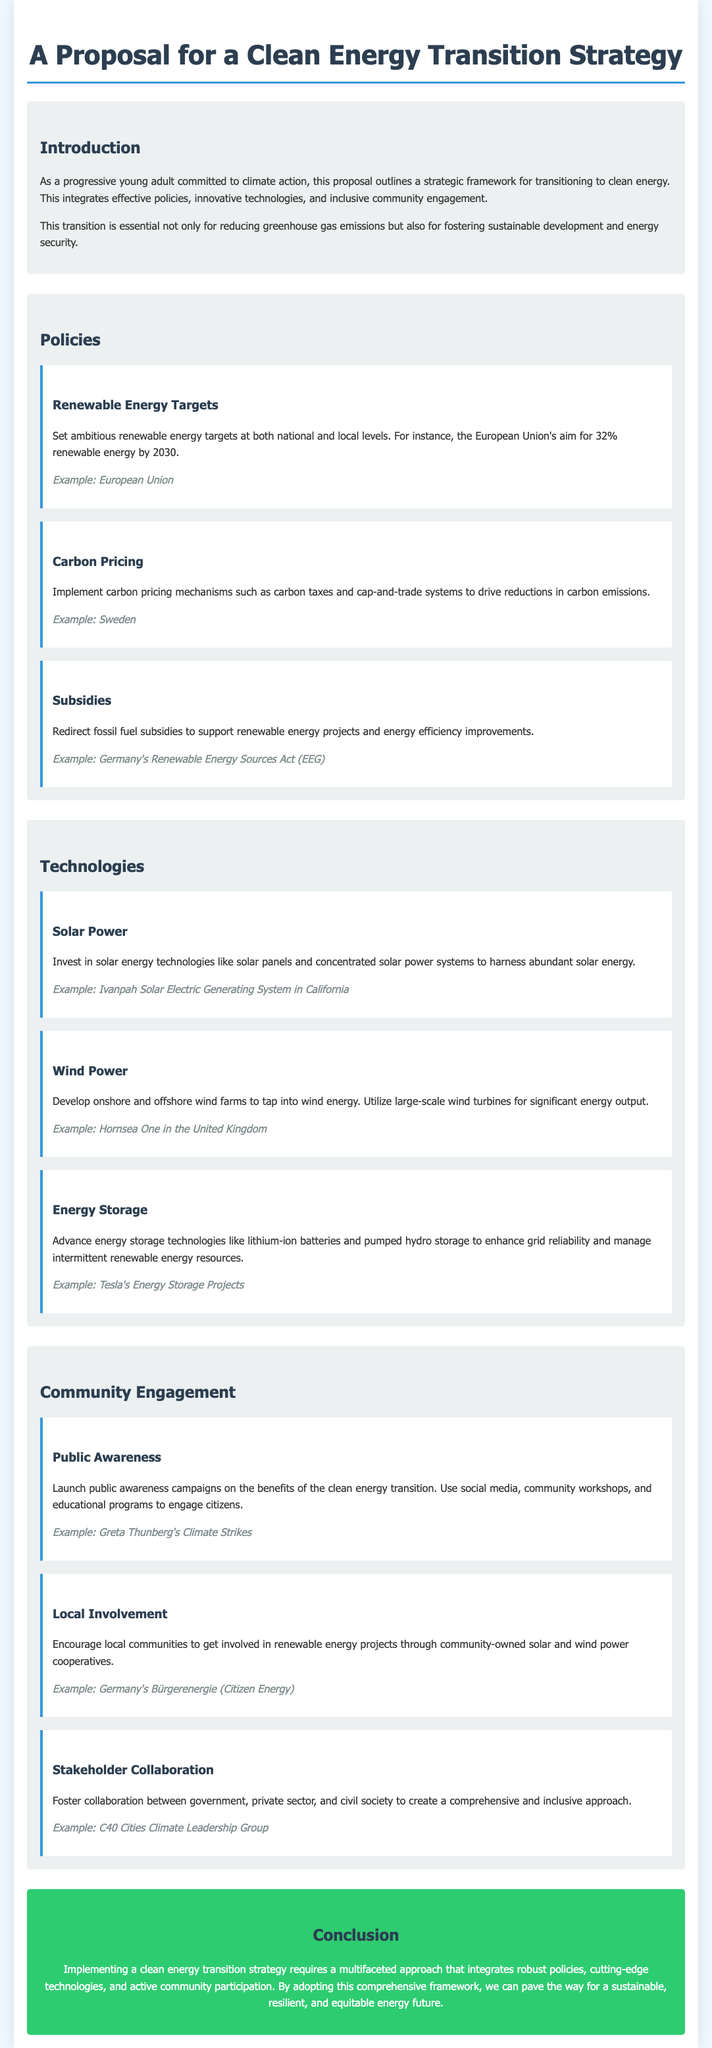What is the main objective of the proposal? The proposal outlines a strategic framework for transitioning to clean energy, which is essential for reducing greenhouse gas emissions and fostering sustainable development and energy security.
Answer: Transition to clean energy What renewable energy target does the European Union aim for? The document specifies the European Union's aim for renewable energy by 2030.
Answer: 32% Which country is mentioned for its carbon pricing mechanisms? The proposal discusses carbon pricing mechanisms implemented in a specific country.
Answer: Sweden Name one technology mentioned for energy storage. The proposal lists several advanced energy storage technologies, one of which is specifically highlighted.
Answer: Lithium-ion batteries What public awareness initiative is referenced as an example? The document includes an example of a public awareness campaign related to climate awareness.
Answer: Greta Thunberg's Climate Strikes What strategy does the proposal recommend for community involvement? Community involvement in renewable energy projects through specific types of cooperatives is suggested.
Answer: Community-owned solar and wind power cooperatives Which group is mentioned for stakeholder collaboration? The proposal identifies a specific group that fosters collaboration between different sectors.
Answer: C40 Cities Climate Leadership Group What is a key component of the proposed clean energy strategy? The document emphasizes the integration of various elements for a successful clean energy transition.
Answer: Robust policies How many sections are included in the proposal? The document is structured into different sections covering various aspects of the proposal.
Answer: Four 